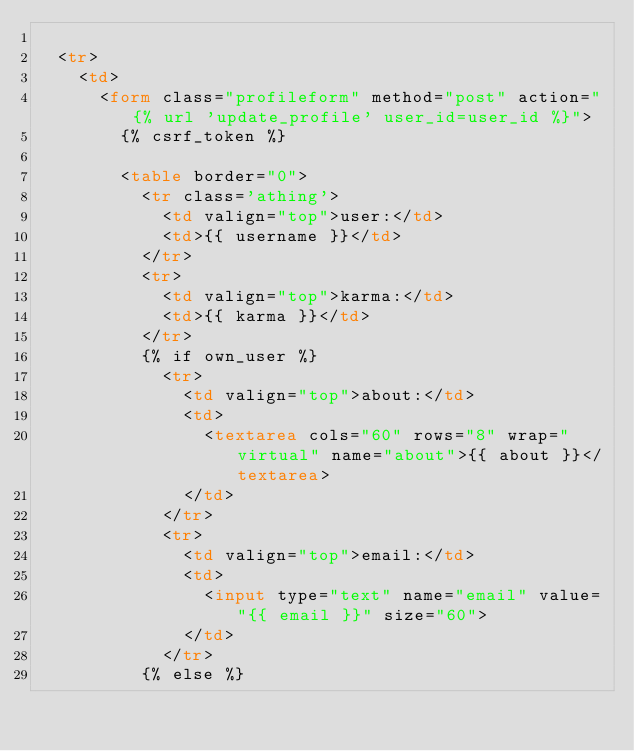<code> <loc_0><loc_0><loc_500><loc_500><_HTML_>
  <tr>
    <td>
      <form class="profileform" method="post" action="{% url 'update_profile' user_id=user_id %}">
        {% csrf_token %}

        <table border="0">
          <tr class='athing'>
            <td valign="top">user:</td>
            <td>{{ username }}</td>
          </tr>
          <tr>
            <td valign="top">karma:</td>
            <td>{{ karma }}</td>
          </tr>
          {% if own_user %}
            <tr>
              <td valign="top">about:</td>
              <td>
                <textarea cols="60" rows="8" wrap="virtual" name="about">{{ about }}</textarea>
              </td>
            </tr>
            <tr>
              <td valign="top">email:</td>
              <td>
                <input type="text" name="email" value="{{ email }}" size="60">
              </td>
            </tr>
          {% else %}</code> 